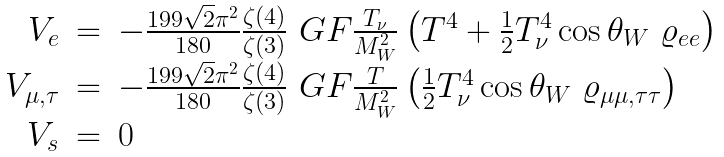Convert formula to latex. <formula><loc_0><loc_0><loc_500><loc_500>\begin{array} { r c l } V _ { e } & = & - \frac { 1 9 9 \sqrt { 2 } \pi ^ { 2 } } { 1 8 0 } \frac { \zeta ( 4 ) } { \zeta ( 3 ) } \ G F \frac { T _ { \nu } } { M _ { W } ^ { 2 } } \left ( T ^ { 4 } + \frac { 1 } { 2 } T _ { \nu } ^ { 4 } \cos \theta _ { W } \ \varrho _ { e e } \right ) \\ V _ { \mu , \tau } & = & - \frac { 1 9 9 \sqrt { 2 } \pi ^ { 2 } } { 1 8 0 } \frac { \zeta ( 4 ) } { \zeta ( 3 ) } \ G F \frac { T } { M _ { W } ^ { 2 } } \left ( \frac { 1 } { 2 } T _ { \nu } ^ { 4 } \cos \theta _ { W } \ \varrho _ { \mu \mu , \tau \tau } \right ) \\ V _ { s } & = & 0 \end{array}</formula> 